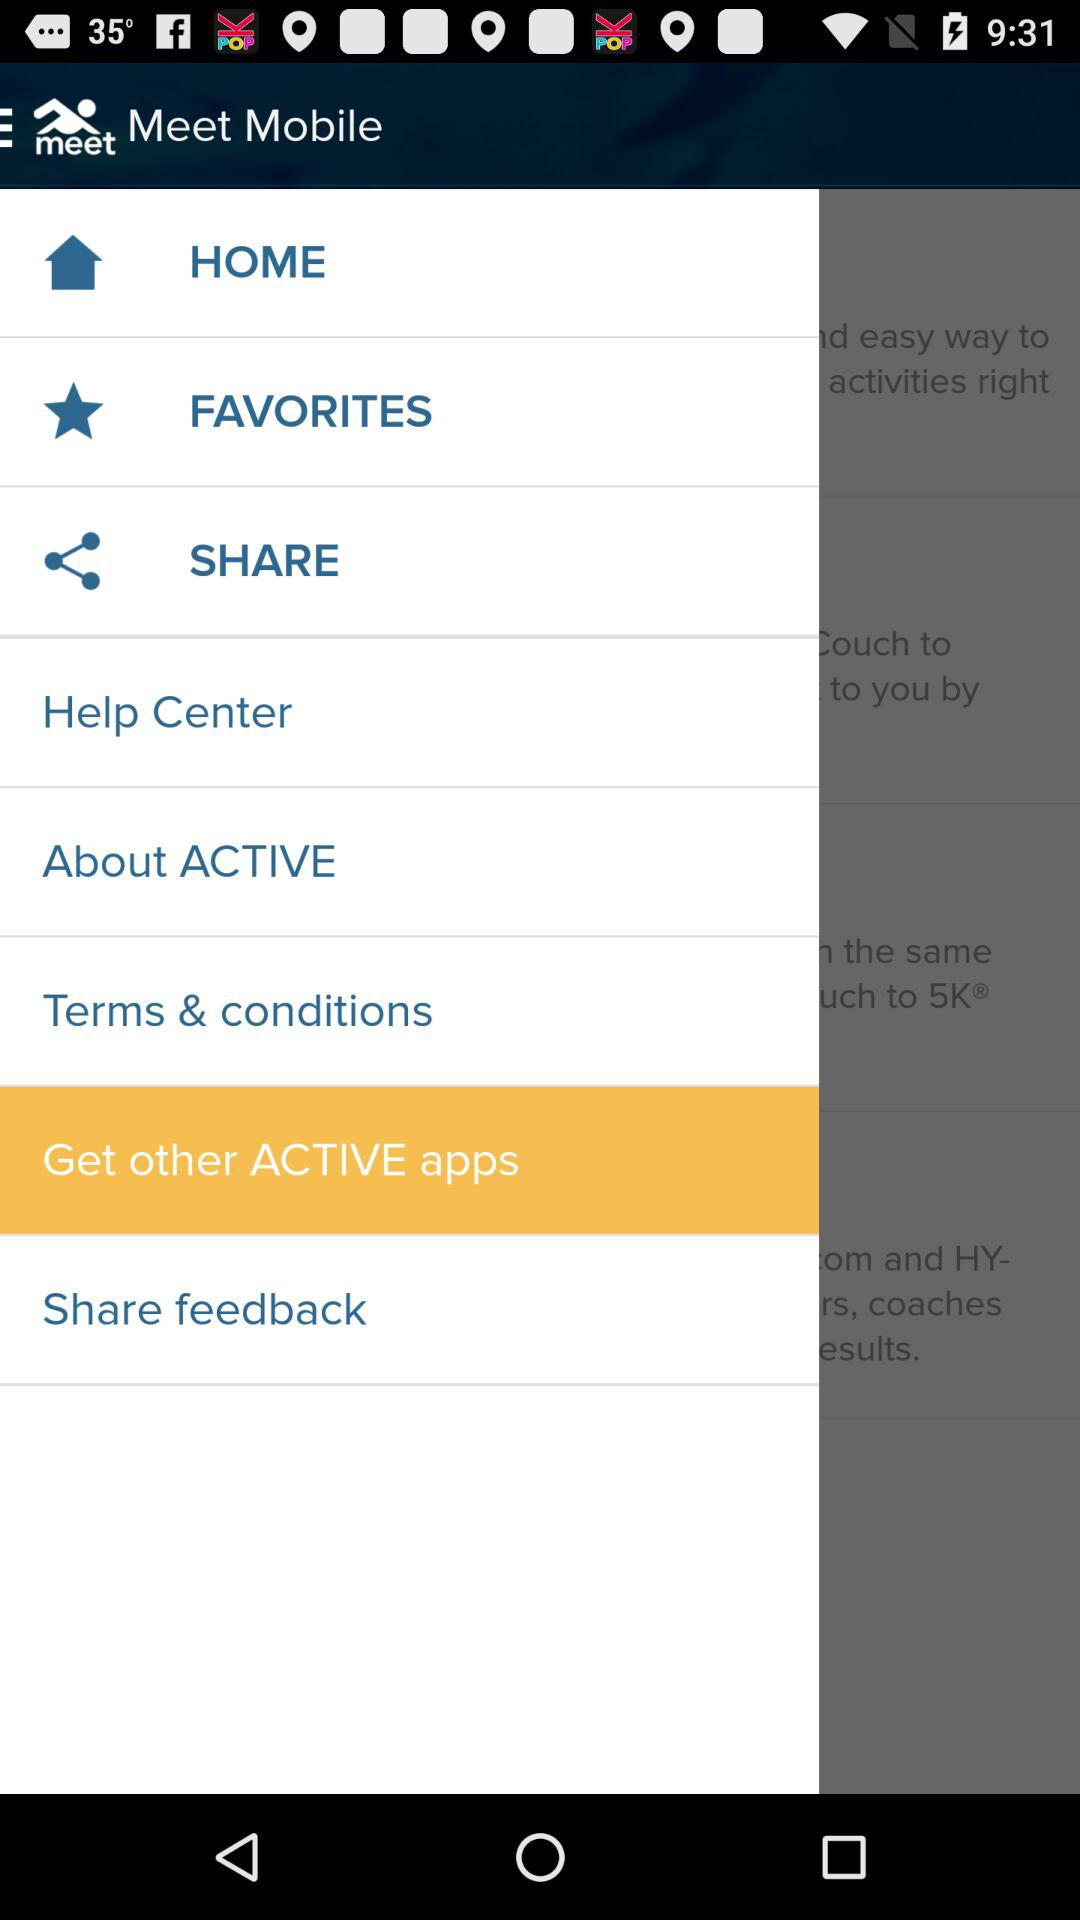What is the application name? The application name is "Meet Mobile". 